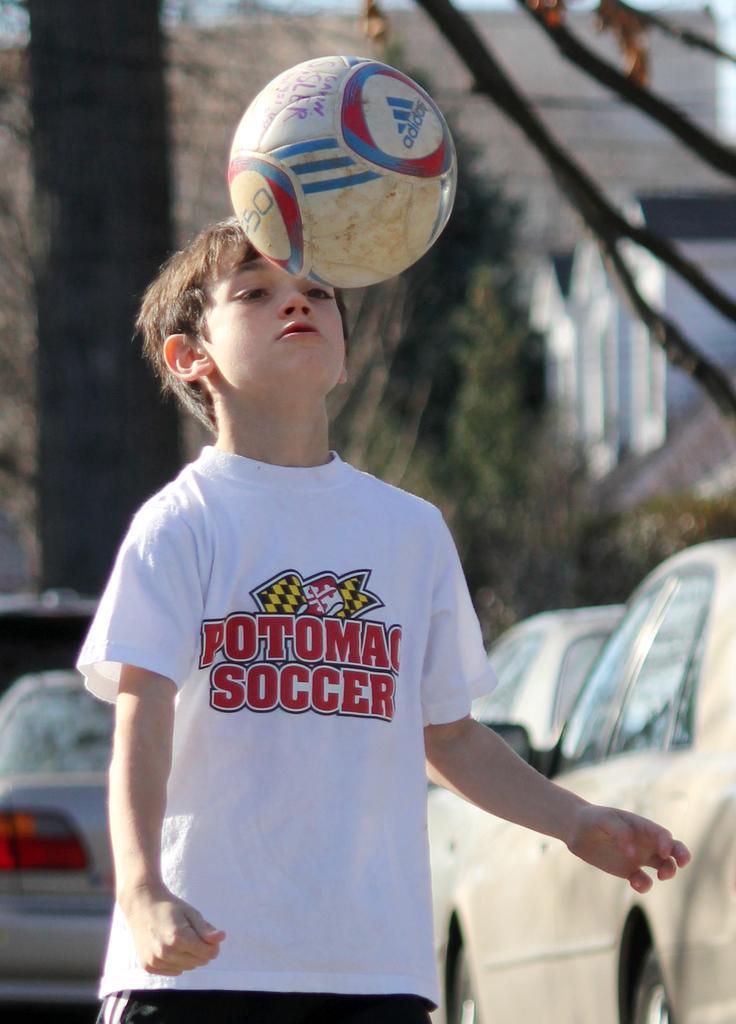Please provide a concise description of this image. This image consists of a boy who is standing. He is wearing white color shirt and black color pant. There is a ball in front of him. Beside him on the right side there are cards and on the left side bottom corner also there is a car. 